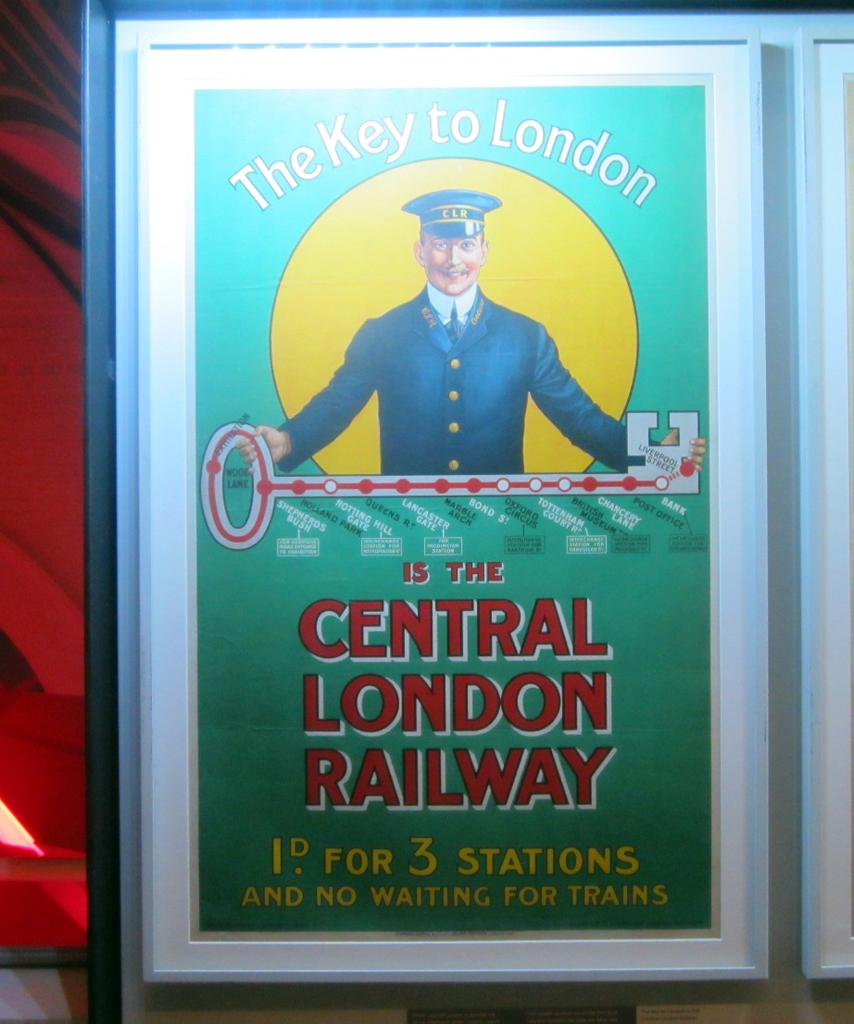<image>
Offer a succinct explanation of the picture presented. the key to London is the Central London Railway, according to this advertisement 